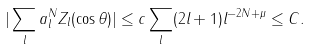<formula> <loc_0><loc_0><loc_500><loc_500>| \sum _ { l } a _ { l } ^ { N } Z _ { l } ( \cos \theta ) | & \leq c \sum _ { l } ( 2 l + 1 ) l ^ { - 2 N + \mu } \leq C .</formula> 